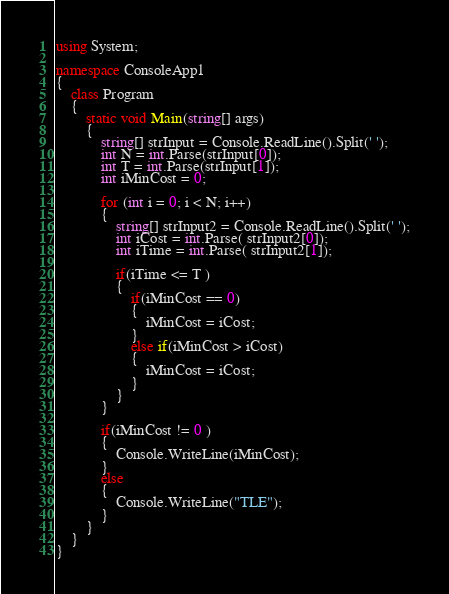<code> <loc_0><loc_0><loc_500><loc_500><_C#_>using System;

namespace ConsoleApp1
{
    class Program
    {
        static void Main(string[] args)
        {
            string[] strInput = Console.ReadLine().Split(' ');
            int N = int.Parse(strInput[0]);
            int T = int.Parse(strInput[1]);
            int iMinCost = 0;

            for (int i = 0; i < N; i++)
            {
                string[] strInput2 = Console.ReadLine().Split(' ');
                int iCost = int.Parse( strInput2[0]);
                int iTime = int.Parse( strInput2[1]);

                if(iTime <= T )
                {
                    if(iMinCost == 0)
                    {
                        iMinCost = iCost;
                    }
                    else if(iMinCost > iCost)
                    {
                        iMinCost = iCost;
                    }
                }
            }

            if(iMinCost != 0 )
            {
                Console.WriteLine(iMinCost);
            }
            else
            {
                Console.WriteLine("TLE");
            }
        }
    }
}</code> 